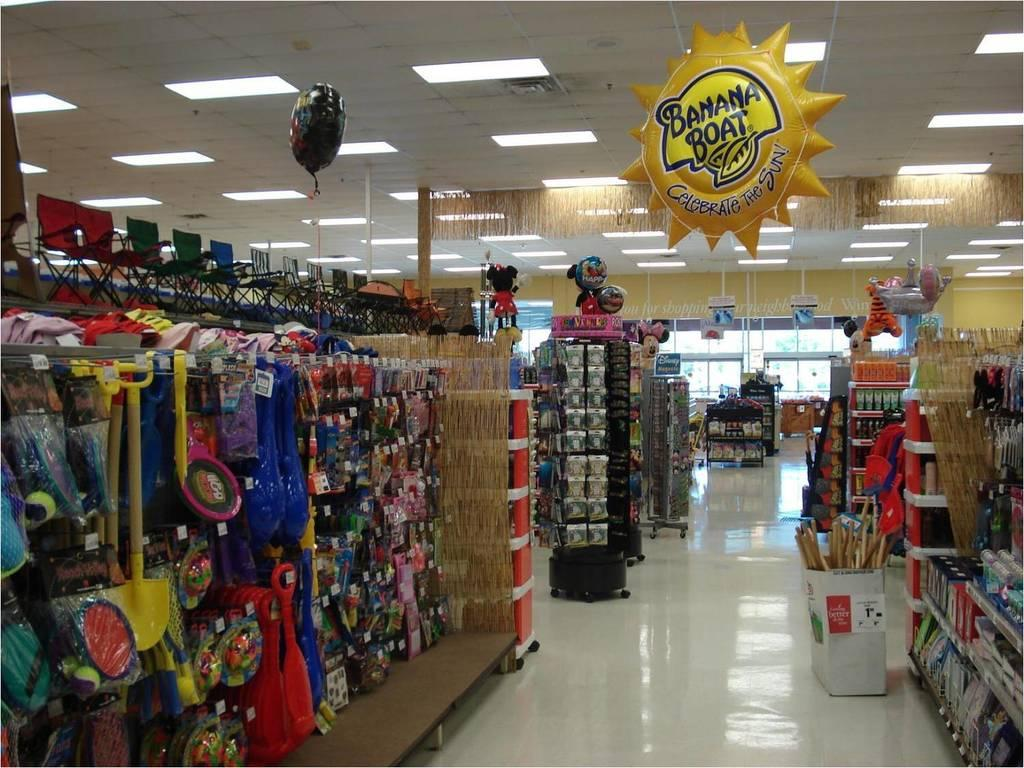<image>
Render a clear and concise summary of the photo. An aisle of a store has a yellow sun hanging from the ceiling that reads, "Banana Boat." 